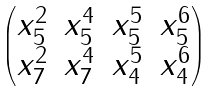Convert formula to latex. <formula><loc_0><loc_0><loc_500><loc_500>\begin{pmatrix} x _ { 5 } ^ { 2 } & x _ { 5 } ^ { 4 } & x _ { 5 } ^ { 5 } & x _ { 5 } ^ { 6 } \\ x _ { 7 } ^ { 2 } & x _ { 7 } ^ { 4 } & x _ { 4 } ^ { 5 } & x _ { 4 } ^ { 6 } \end{pmatrix}</formula> 